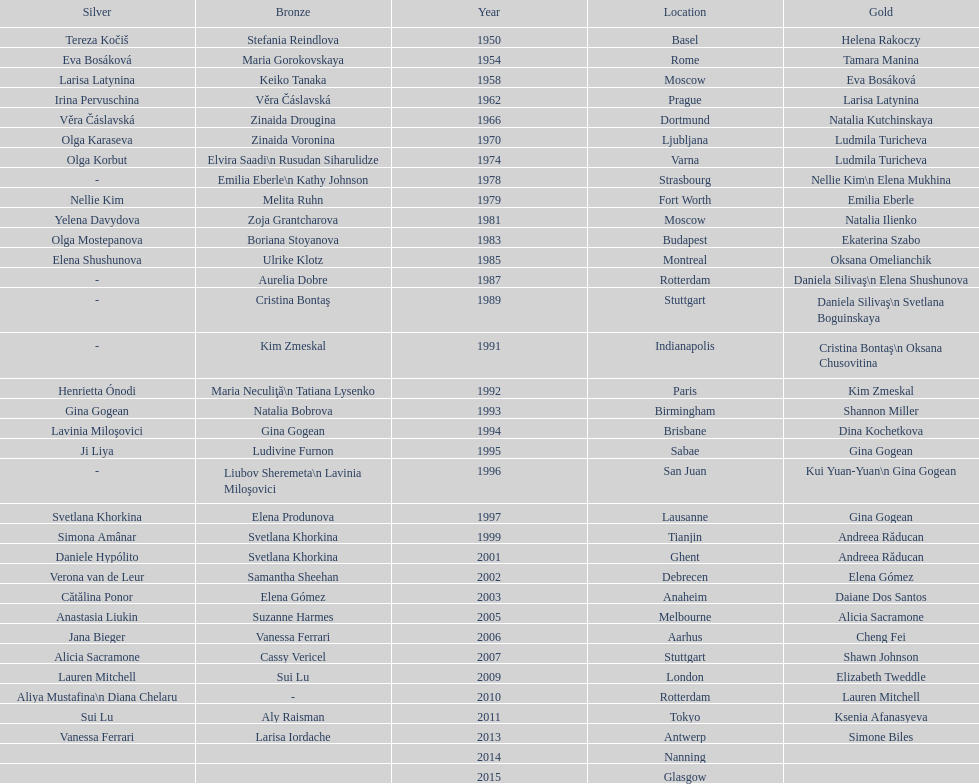Which two american rivals won consecutive floor exercise gold medals at the artistic gymnastics world championships in 1992 and 1993? Kim Zmeskal, Shannon Miller. 